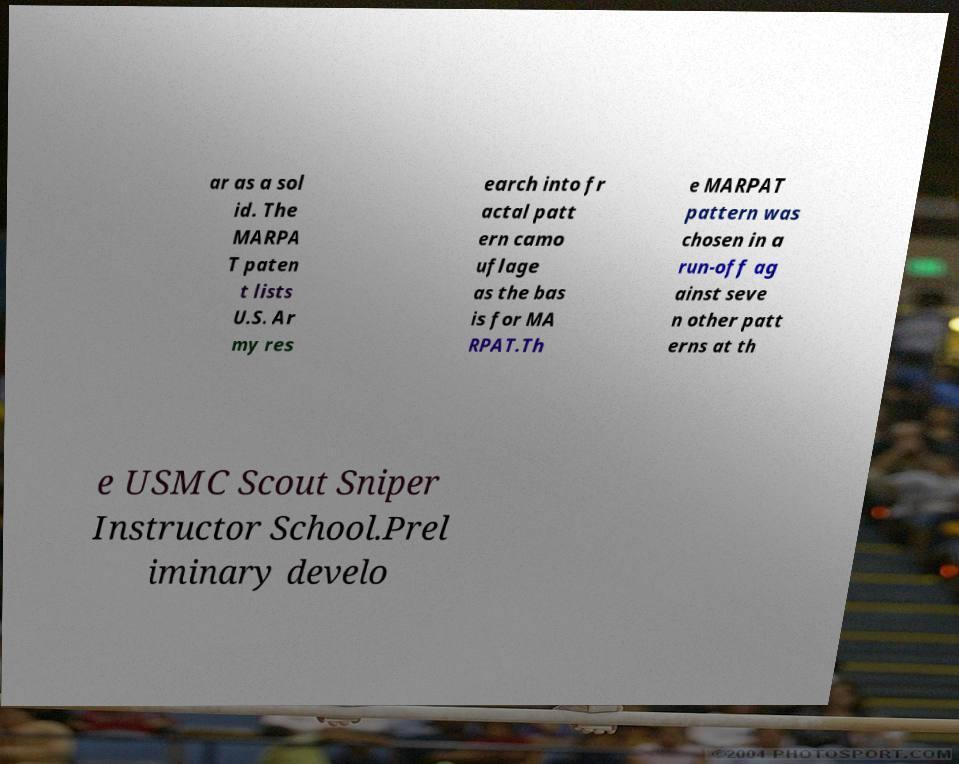Could you extract and type out the text from this image? ar as a sol id. The MARPA T paten t lists U.S. Ar my res earch into fr actal patt ern camo uflage as the bas is for MA RPAT.Th e MARPAT pattern was chosen in a run-off ag ainst seve n other patt erns at th e USMC Scout Sniper Instructor School.Prel iminary develo 